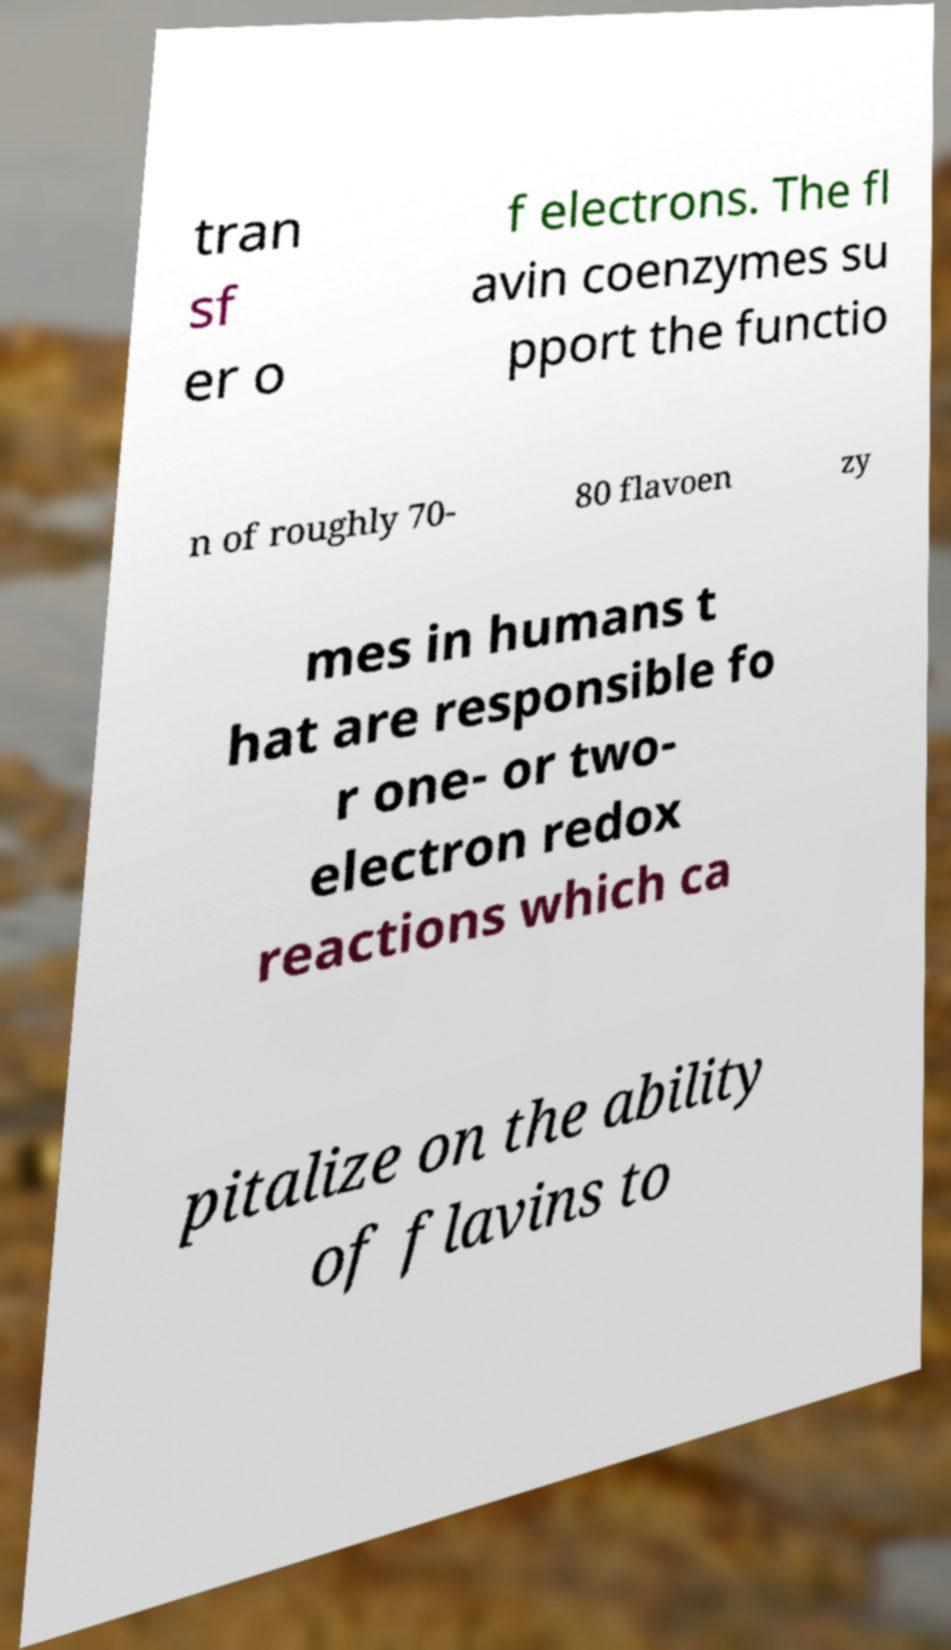What messages or text are displayed in this image? I need them in a readable, typed format. tran sf er o f electrons. The fl avin coenzymes su pport the functio n of roughly 70- 80 flavoen zy mes in humans t hat are responsible fo r one- or two- electron redox reactions which ca pitalize on the ability of flavins to 